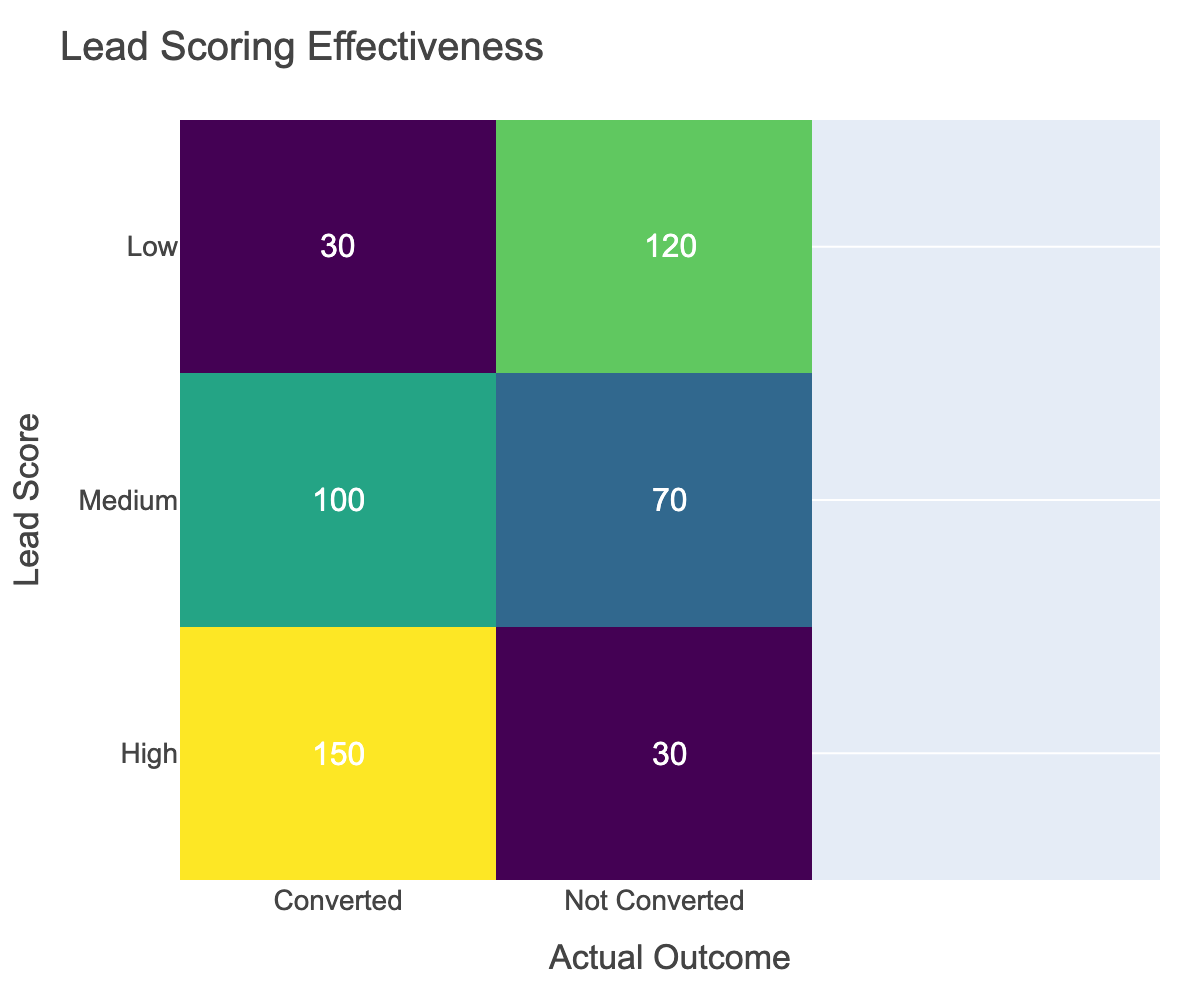What is the number of converted leads with a high score? The table shows that for leads with a high score, the number of converted leads is listed as 150.
Answer: 150 What is the total number of leads that did not convert? To find the total number of leads that did not convert, we can sum the "Not Converted" values from each lead score category: 30 + 70 + 120 = 220.
Answer: 220 Is it true that more medium scored leads converted than low scored leads? From the table, medium scored leads converted 100, while low scored leads converted only 30, so it is true that more medium scored leads converted than low scored leads.
Answer: Yes What is the average number of converted leads across all lead scores? To find the average, we sum the converted leads: 150 + 100 + 30 = 280. Then we divide by the number of categories (3): 280 / 3 = approximately 93.33.
Answer: 93.33 How many more leads converted in the high category compared to the low category? The high category has 150 converted leads, and the low category has 30. The difference is 150 - 30 = 120 leads.
Answer: 120 What percentage of leads with a low score did not convert? The number of not converted leads in the low category is 120, and the total leads in this category is 30 (converted) + 120 (not converted) = 150. The percentage of leads that did not convert is (120 / 150) * 100 = 80%.
Answer: 80% Which lead score category has the highest total number of leads? To find the total number of leads for each category, we add the converted and not converted leads. For high: 150 + 30 = 180, for medium: 100 + 70 = 170, and for low: 30 + 120 = 150. The highest total is from the high category with 180 leads.
Answer: High How many leads with a medium score did not convert? From the table, the number of leads with a medium score that did not convert is directly provided as 70.
Answer: 70 